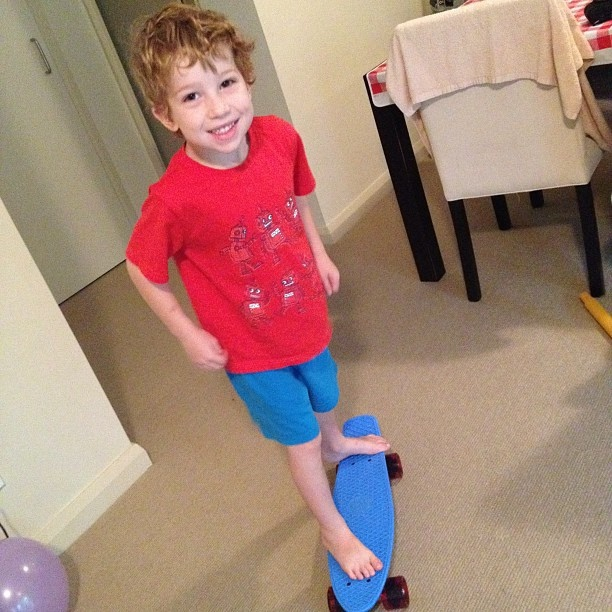Describe the objects in this image and their specific colors. I can see people in tan, red, brown, and lightpink tones, chair in tan and black tones, dining table in tan, black, lightpink, and darkgray tones, skateboard in tan, gray, and black tones, and sports ball in tan, darkgray, gray, and lavender tones in this image. 